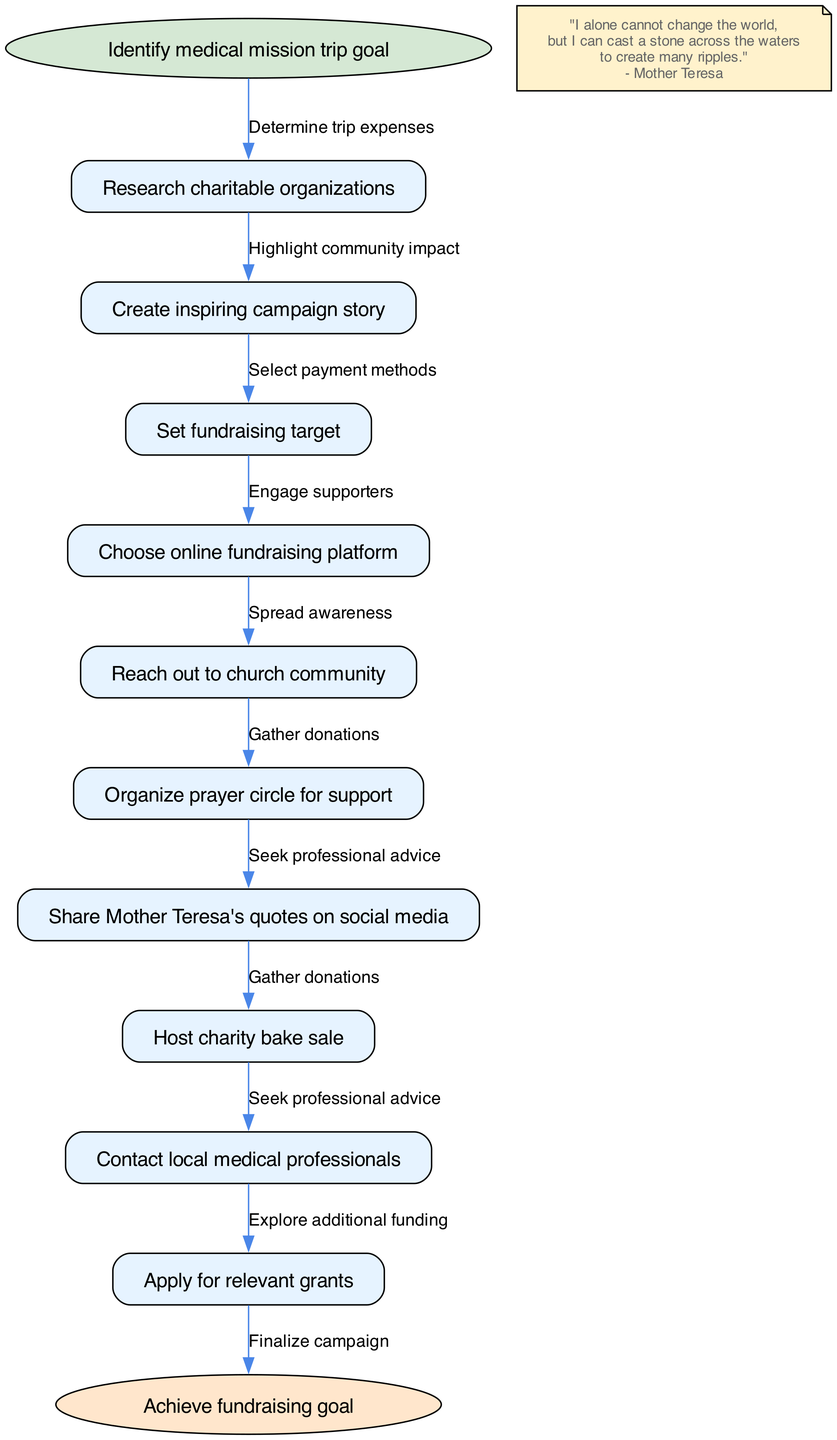What is the starting point of the fundraising campaign? The starting point of the diagram is clearly labeled as "Identify medical mission trip goal". This node represents the initial step before any actions are taken.
Answer: Identify medical mission trip goal How many nodes are in the diagram? The diagram includes a total of 11 nodes: 1 start node, 9 intermediate nodes, and 1 end node. Counting each of them results in 11.
Answer: 11 What is the end goal of the fundraising campaign? The end node states "Achieve fundraising goal", which is the final objective of this flow chart.
Answer: Achieve fundraising goal Which node follows the "Create inspiring campaign story"? The node that directly follows "Create inspiring campaign story" is "Set fundraising target". This shows the progression from developing a narrative to establishing a financial objective.
Answer: Set fundraising target What edge connects "Reach out to church community" to the next node? The edge connecting "Reach out to church community" to the next node states "Engage supporters", indicating the purpose of this outreach is to involve church members.
Answer: Engage supporters How many edges are used to connect the nodes? There are 9 edges in total, each connecting a pair of nodes to represent the flow of steps in the fundraising process. Counting them from start to end confirms there are 9 connections.
Answer: 9 What is the relationship between "Organize prayer circle for support" and "Share Mother Teresa's quotes on social media"? The diagram indicates that "Organize prayer circle for support" leads to the next action, which is "Share Mother Teresa's quotes on social media" directly connected through the edge labeled "Spread awareness".
Answer: Spread awareness What quote from Mother Teresa is included in the diagram? The quote included in the diagram is: "I alone cannot change the world, but I can cast a stone across the waters to create many ripples." This is meant to inspire action and connection to the campaign.
Answer: "I alone cannot change the world, but I can cast a stone across the waters to create many ripples." Which node corresponds to the action of applying for financial support? The node that corresponds to applying for financial support is "Apply for relevant grants". This step is part of exploring funding avenues available for the mission trip.
Answer: Apply for relevant grants 